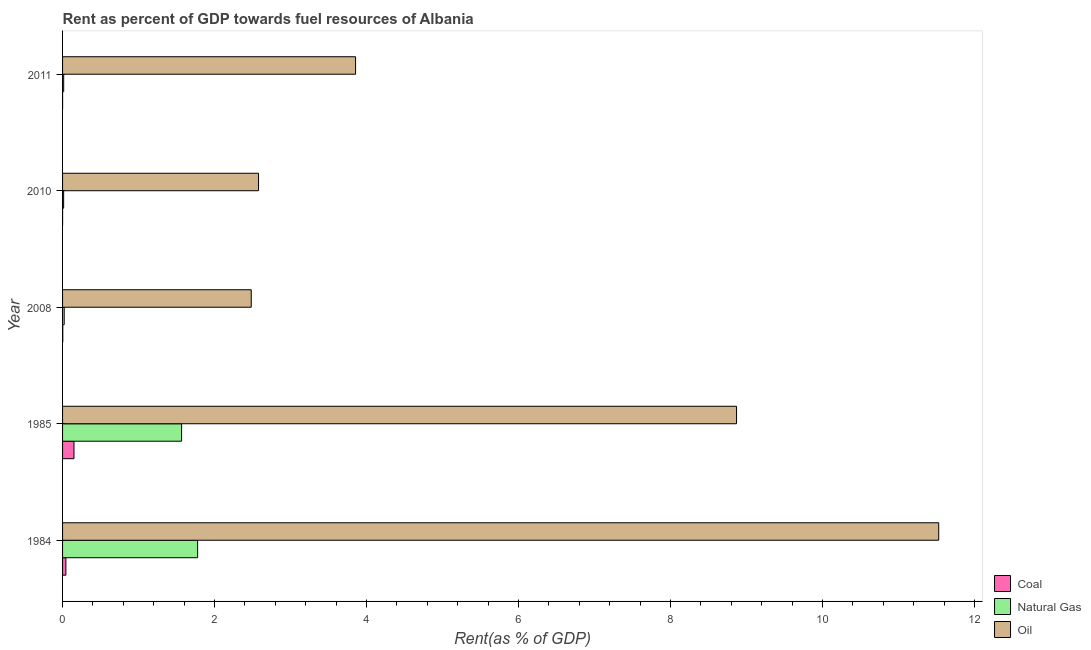How many groups of bars are there?
Provide a short and direct response. 5. How many bars are there on the 3rd tick from the bottom?
Your answer should be compact. 3. What is the rent towards coal in 2010?
Your response must be concise. 0. Across all years, what is the maximum rent towards coal?
Give a very brief answer. 0.15. Across all years, what is the minimum rent towards coal?
Your answer should be compact. 0. In which year was the rent towards oil minimum?
Offer a terse response. 2008. What is the total rent towards coal in the graph?
Your response must be concise. 0.2. What is the difference between the rent towards coal in 1984 and that in 2010?
Your answer should be very brief. 0.04. What is the difference between the rent towards coal in 1984 and the rent towards natural gas in 2010?
Provide a succinct answer. 0.03. What is the average rent towards natural gas per year?
Your answer should be compact. 0.68. In the year 2008, what is the difference between the rent towards oil and rent towards coal?
Your response must be concise. 2.48. In how many years, is the rent towards natural gas greater than 1.2000000000000002 %?
Offer a very short reply. 2. What is the ratio of the rent towards coal in 1984 to that in 2011?
Provide a short and direct response. 172.49. What is the difference between the highest and the second highest rent towards natural gas?
Offer a terse response. 0.21. What is the difference between the highest and the lowest rent towards natural gas?
Offer a terse response. 1.76. In how many years, is the rent towards coal greater than the average rent towards coal taken over all years?
Keep it short and to the point. 2. Is the sum of the rent towards natural gas in 1985 and 2008 greater than the maximum rent towards oil across all years?
Your answer should be compact. No. What does the 1st bar from the top in 1984 represents?
Your answer should be compact. Oil. What does the 1st bar from the bottom in 1985 represents?
Offer a terse response. Coal. How many years are there in the graph?
Keep it short and to the point. 5. Does the graph contain any zero values?
Offer a very short reply. No. Where does the legend appear in the graph?
Offer a terse response. Bottom right. What is the title of the graph?
Make the answer very short. Rent as percent of GDP towards fuel resources of Albania. Does "Secondary education" appear as one of the legend labels in the graph?
Provide a succinct answer. No. What is the label or title of the X-axis?
Give a very brief answer. Rent(as % of GDP). What is the Rent(as % of GDP) in Coal in 1984?
Ensure brevity in your answer.  0.04. What is the Rent(as % of GDP) in Natural Gas in 1984?
Offer a very short reply. 1.78. What is the Rent(as % of GDP) in Oil in 1984?
Provide a short and direct response. 11.53. What is the Rent(as % of GDP) in Coal in 1985?
Provide a succinct answer. 0.15. What is the Rent(as % of GDP) of Natural Gas in 1985?
Make the answer very short. 1.57. What is the Rent(as % of GDP) of Oil in 1985?
Ensure brevity in your answer.  8.87. What is the Rent(as % of GDP) of Coal in 2008?
Keep it short and to the point. 0. What is the Rent(as % of GDP) in Natural Gas in 2008?
Ensure brevity in your answer.  0.02. What is the Rent(as % of GDP) of Oil in 2008?
Give a very brief answer. 2.48. What is the Rent(as % of GDP) of Coal in 2010?
Provide a short and direct response. 0. What is the Rent(as % of GDP) in Natural Gas in 2010?
Your response must be concise. 0.01. What is the Rent(as % of GDP) in Oil in 2010?
Offer a very short reply. 2.58. What is the Rent(as % of GDP) of Coal in 2011?
Provide a succinct answer. 0. What is the Rent(as % of GDP) of Natural Gas in 2011?
Provide a succinct answer. 0.01. What is the Rent(as % of GDP) of Oil in 2011?
Offer a very short reply. 3.86. Across all years, what is the maximum Rent(as % of GDP) in Coal?
Provide a short and direct response. 0.15. Across all years, what is the maximum Rent(as % of GDP) in Natural Gas?
Provide a succinct answer. 1.78. Across all years, what is the maximum Rent(as % of GDP) in Oil?
Give a very brief answer. 11.53. Across all years, what is the minimum Rent(as % of GDP) of Coal?
Provide a succinct answer. 0. Across all years, what is the minimum Rent(as % of GDP) of Natural Gas?
Make the answer very short. 0.01. Across all years, what is the minimum Rent(as % of GDP) in Oil?
Make the answer very short. 2.48. What is the total Rent(as % of GDP) in Coal in the graph?
Offer a terse response. 0.2. What is the total Rent(as % of GDP) in Natural Gas in the graph?
Ensure brevity in your answer.  3.39. What is the total Rent(as % of GDP) in Oil in the graph?
Provide a succinct answer. 29.32. What is the difference between the Rent(as % of GDP) in Coal in 1984 and that in 1985?
Offer a terse response. -0.11. What is the difference between the Rent(as % of GDP) in Natural Gas in 1984 and that in 1985?
Keep it short and to the point. 0.21. What is the difference between the Rent(as % of GDP) of Oil in 1984 and that in 1985?
Provide a succinct answer. 2.66. What is the difference between the Rent(as % of GDP) in Coal in 1984 and that in 2008?
Your answer should be very brief. 0.04. What is the difference between the Rent(as % of GDP) in Natural Gas in 1984 and that in 2008?
Provide a succinct answer. 1.76. What is the difference between the Rent(as % of GDP) in Oil in 1984 and that in 2008?
Give a very brief answer. 9.05. What is the difference between the Rent(as % of GDP) in Coal in 1984 and that in 2010?
Your response must be concise. 0.04. What is the difference between the Rent(as % of GDP) in Natural Gas in 1984 and that in 2010?
Make the answer very short. 1.76. What is the difference between the Rent(as % of GDP) of Oil in 1984 and that in 2010?
Provide a short and direct response. 8.95. What is the difference between the Rent(as % of GDP) of Coal in 1984 and that in 2011?
Give a very brief answer. 0.04. What is the difference between the Rent(as % of GDP) of Natural Gas in 1984 and that in 2011?
Your response must be concise. 1.76. What is the difference between the Rent(as % of GDP) of Oil in 1984 and that in 2011?
Offer a very short reply. 7.67. What is the difference between the Rent(as % of GDP) in Coal in 1985 and that in 2008?
Keep it short and to the point. 0.15. What is the difference between the Rent(as % of GDP) of Natural Gas in 1985 and that in 2008?
Your response must be concise. 1.54. What is the difference between the Rent(as % of GDP) of Oil in 1985 and that in 2008?
Provide a short and direct response. 6.39. What is the difference between the Rent(as % of GDP) of Coal in 1985 and that in 2010?
Offer a terse response. 0.15. What is the difference between the Rent(as % of GDP) in Natural Gas in 1985 and that in 2010?
Keep it short and to the point. 1.55. What is the difference between the Rent(as % of GDP) in Oil in 1985 and that in 2010?
Ensure brevity in your answer.  6.29. What is the difference between the Rent(as % of GDP) in Coal in 1985 and that in 2011?
Ensure brevity in your answer.  0.15. What is the difference between the Rent(as % of GDP) of Natural Gas in 1985 and that in 2011?
Keep it short and to the point. 1.55. What is the difference between the Rent(as % of GDP) of Oil in 1985 and that in 2011?
Give a very brief answer. 5.01. What is the difference between the Rent(as % of GDP) of Coal in 2008 and that in 2010?
Your response must be concise. 0. What is the difference between the Rent(as % of GDP) of Natural Gas in 2008 and that in 2010?
Your response must be concise. 0.01. What is the difference between the Rent(as % of GDP) of Oil in 2008 and that in 2010?
Make the answer very short. -0.1. What is the difference between the Rent(as % of GDP) in Coal in 2008 and that in 2011?
Make the answer very short. 0. What is the difference between the Rent(as % of GDP) in Natural Gas in 2008 and that in 2011?
Your answer should be very brief. 0.01. What is the difference between the Rent(as % of GDP) in Oil in 2008 and that in 2011?
Give a very brief answer. -1.37. What is the difference between the Rent(as % of GDP) of Coal in 2010 and that in 2011?
Ensure brevity in your answer.  -0. What is the difference between the Rent(as % of GDP) in Natural Gas in 2010 and that in 2011?
Offer a terse response. -0. What is the difference between the Rent(as % of GDP) in Oil in 2010 and that in 2011?
Your answer should be compact. -1.28. What is the difference between the Rent(as % of GDP) of Coal in 1984 and the Rent(as % of GDP) of Natural Gas in 1985?
Offer a terse response. -1.52. What is the difference between the Rent(as % of GDP) of Coal in 1984 and the Rent(as % of GDP) of Oil in 1985?
Your response must be concise. -8.83. What is the difference between the Rent(as % of GDP) of Natural Gas in 1984 and the Rent(as % of GDP) of Oil in 1985?
Provide a succinct answer. -7.09. What is the difference between the Rent(as % of GDP) in Coal in 1984 and the Rent(as % of GDP) in Natural Gas in 2008?
Your response must be concise. 0.02. What is the difference between the Rent(as % of GDP) of Coal in 1984 and the Rent(as % of GDP) of Oil in 2008?
Make the answer very short. -2.44. What is the difference between the Rent(as % of GDP) in Natural Gas in 1984 and the Rent(as % of GDP) in Oil in 2008?
Your response must be concise. -0.71. What is the difference between the Rent(as % of GDP) of Coal in 1984 and the Rent(as % of GDP) of Natural Gas in 2010?
Keep it short and to the point. 0.03. What is the difference between the Rent(as % of GDP) in Coal in 1984 and the Rent(as % of GDP) in Oil in 2010?
Give a very brief answer. -2.54. What is the difference between the Rent(as % of GDP) in Natural Gas in 1984 and the Rent(as % of GDP) in Oil in 2010?
Your answer should be compact. -0.8. What is the difference between the Rent(as % of GDP) in Coal in 1984 and the Rent(as % of GDP) in Natural Gas in 2011?
Keep it short and to the point. 0.03. What is the difference between the Rent(as % of GDP) of Coal in 1984 and the Rent(as % of GDP) of Oil in 2011?
Make the answer very short. -3.81. What is the difference between the Rent(as % of GDP) in Natural Gas in 1984 and the Rent(as % of GDP) in Oil in 2011?
Your response must be concise. -2.08. What is the difference between the Rent(as % of GDP) of Coal in 1985 and the Rent(as % of GDP) of Natural Gas in 2008?
Keep it short and to the point. 0.13. What is the difference between the Rent(as % of GDP) in Coal in 1985 and the Rent(as % of GDP) in Oil in 2008?
Keep it short and to the point. -2.33. What is the difference between the Rent(as % of GDP) in Natural Gas in 1985 and the Rent(as % of GDP) in Oil in 2008?
Keep it short and to the point. -0.92. What is the difference between the Rent(as % of GDP) of Coal in 1985 and the Rent(as % of GDP) of Natural Gas in 2010?
Your response must be concise. 0.14. What is the difference between the Rent(as % of GDP) in Coal in 1985 and the Rent(as % of GDP) in Oil in 2010?
Make the answer very short. -2.43. What is the difference between the Rent(as % of GDP) of Natural Gas in 1985 and the Rent(as % of GDP) of Oil in 2010?
Keep it short and to the point. -1.01. What is the difference between the Rent(as % of GDP) in Coal in 1985 and the Rent(as % of GDP) in Natural Gas in 2011?
Your answer should be compact. 0.14. What is the difference between the Rent(as % of GDP) of Coal in 1985 and the Rent(as % of GDP) of Oil in 2011?
Give a very brief answer. -3.71. What is the difference between the Rent(as % of GDP) in Natural Gas in 1985 and the Rent(as % of GDP) in Oil in 2011?
Provide a succinct answer. -2.29. What is the difference between the Rent(as % of GDP) in Coal in 2008 and the Rent(as % of GDP) in Natural Gas in 2010?
Offer a terse response. -0.01. What is the difference between the Rent(as % of GDP) in Coal in 2008 and the Rent(as % of GDP) in Oil in 2010?
Offer a terse response. -2.58. What is the difference between the Rent(as % of GDP) in Natural Gas in 2008 and the Rent(as % of GDP) in Oil in 2010?
Keep it short and to the point. -2.56. What is the difference between the Rent(as % of GDP) in Coal in 2008 and the Rent(as % of GDP) in Natural Gas in 2011?
Provide a short and direct response. -0.01. What is the difference between the Rent(as % of GDP) of Coal in 2008 and the Rent(as % of GDP) of Oil in 2011?
Your response must be concise. -3.85. What is the difference between the Rent(as % of GDP) in Natural Gas in 2008 and the Rent(as % of GDP) in Oil in 2011?
Your response must be concise. -3.83. What is the difference between the Rent(as % of GDP) of Coal in 2010 and the Rent(as % of GDP) of Natural Gas in 2011?
Your response must be concise. -0.01. What is the difference between the Rent(as % of GDP) of Coal in 2010 and the Rent(as % of GDP) of Oil in 2011?
Keep it short and to the point. -3.86. What is the difference between the Rent(as % of GDP) in Natural Gas in 2010 and the Rent(as % of GDP) in Oil in 2011?
Your answer should be compact. -3.84. What is the average Rent(as % of GDP) in Coal per year?
Offer a very short reply. 0.04. What is the average Rent(as % of GDP) in Natural Gas per year?
Your response must be concise. 0.68. What is the average Rent(as % of GDP) of Oil per year?
Your answer should be compact. 5.86. In the year 1984, what is the difference between the Rent(as % of GDP) in Coal and Rent(as % of GDP) in Natural Gas?
Offer a very short reply. -1.73. In the year 1984, what is the difference between the Rent(as % of GDP) in Coal and Rent(as % of GDP) in Oil?
Offer a terse response. -11.49. In the year 1984, what is the difference between the Rent(as % of GDP) of Natural Gas and Rent(as % of GDP) of Oil?
Your response must be concise. -9.75. In the year 1985, what is the difference between the Rent(as % of GDP) of Coal and Rent(as % of GDP) of Natural Gas?
Keep it short and to the point. -1.42. In the year 1985, what is the difference between the Rent(as % of GDP) of Coal and Rent(as % of GDP) of Oil?
Offer a very short reply. -8.72. In the year 1985, what is the difference between the Rent(as % of GDP) of Natural Gas and Rent(as % of GDP) of Oil?
Give a very brief answer. -7.3. In the year 2008, what is the difference between the Rent(as % of GDP) of Coal and Rent(as % of GDP) of Natural Gas?
Keep it short and to the point. -0.02. In the year 2008, what is the difference between the Rent(as % of GDP) in Coal and Rent(as % of GDP) in Oil?
Provide a short and direct response. -2.48. In the year 2008, what is the difference between the Rent(as % of GDP) in Natural Gas and Rent(as % of GDP) in Oil?
Offer a very short reply. -2.46. In the year 2010, what is the difference between the Rent(as % of GDP) in Coal and Rent(as % of GDP) in Natural Gas?
Make the answer very short. -0.01. In the year 2010, what is the difference between the Rent(as % of GDP) in Coal and Rent(as % of GDP) in Oil?
Your response must be concise. -2.58. In the year 2010, what is the difference between the Rent(as % of GDP) in Natural Gas and Rent(as % of GDP) in Oil?
Keep it short and to the point. -2.56. In the year 2011, what is the difference between the Rent(as % of GDP) in Coal and Rent(as % of GDP) in Natural Gas?
Your answer should be very brief. -0.01. In the year 2011, what is the difference between the Rent(as % of GDP) in Coal and Rent(as % of GDP) in Oil?
Give a very brief answer. -3.86. In the year 2011, what is the difference between the Rent(as % of GDP) in Natural Gas and Rent(as % of GDP) in Oil?
Give a very brief answer. -3.84. What is the ratio of the Rent(as % of GDP) of Coal in 1984 to that in 1985?
Give a very brief answer. 0.29. What is the ratio of the Rent(as % of GDP) of Natural Gas in 1984 to that in 1985?
Keep it short and to the point. 1.13. What is the ratio of the Rent(as % of GDP) of Oil in 1984 to that in 1985?
Your answer should be very brief. 1.3. What is the ratio of the Rent(as % of GDP) in Coal in 1984 to that in 2008?
Your answer should be compact. 14.99. What is the ratio of the Rent(as % of GDP) in Natural Gas in 1984 to that in 2008?
Provide a short and direct response. 82.85. What is the ratio of the Rent(as % of GDP) of Oil in 1984 to that in 2008?
Provide a short and direct response. 4.64. What is the ratio of the Rent(as % of GDP) of Coal in 1984 to that in 2010?
Make the answer very short. 347.91. What is the ratio of the Rent(as % of GDP) of Natural Gas in 1984 to that in 2010?
Give a very brief answer. 125.7. What is the ratio of the Rent(as % of GDP) of Oil in 1984 to that in 2010?
Offer a terse response. 4.47. What is the ratio of the Rent(as % of GDP) in Coal in 1984 to that in 2011?
Keep it short and to the point. 172.49. What is the ratio of the Rent(as % of GDP) in Natural Gas in 1984 to that in 2011?
Provide a succinct answer. 120.52. What is the ratio of the Rent(as % of GDP) in Oil in 1984 to that in 2011?
Keep it short and to the point. 2.99. What is the ratio of the Rent(as % of GDP) in Coal in 1985 to that in 2008?
Your answer should be very brief. 51.55. What is the ratio of the Rent(as % of GDP) in Natural Gas in 1985 to that in 2008?
Make the answer very short. 73.02. What is the ratio of the Rent(as % of GDP) in Oil in 1985 to that in 2008?
Give a very brief answer. 3.57. What is the ratio of the Rent(as % of GDP) in Coal in 1985 to that in 2010?
Offer a very short reply. 1196.46. What is the ratio of the Rent(as % of GDP) in Natural Gas in 1985 to that in 2010?
Ensure brevity in your answer.  110.78. What is the ratio of the Rent(as % of GDP) in Oil in 1985 to that in 2010?
Your answer should be compact. 3.44. What is the ratio of the Rent(as % of GDP) of Coal in 1985 to that in 2011?
Your response must be concise. 593.21. What is the ratio of the Rent(as % of GDP) of Natural Gas in 1985 to that in 2011?
Your answer should be compact. 106.22. What is the ratio of the Rent(as % of GDP) in Oil in 1985 to that in 2011?
Your response must be concise. 2.3. What is the ratio of the Rent(as % of GDP) in Coal in 2008 to that in 2010?
Offer a very short reply. 23.21. What is the ratio of the Rent(as % of GDP) of Natural Gas in 2008 to that in 2010?
Your answer should be very brief. 1.52. What is the ratio of the Rent(as % of GDP) of Oil in 2008 to that in 2010?
Provide a short and direct response. 0.96. What is the ratio of the Rent(as % of GDP) of Coal in 2008 to that in 2011?
Offer a terse response. 11.51. What is the ratio of the Rent(as % of GDP) in Natural Gas in 2008 to that in 2011?
Keep it short and to the point. 1.45. What is the ratio of the Rent(as % of GDP) of Oil in 2008 to that in 2011?
Make the answer very short. 0.64. What is the ratio of the Rent(as % of GDP) of Coal in 2010 to that in 2011?
Make the answer very short. 0.5. What is the ratio of the Rent(as % of GDP) in Natural Gas in 2010 to that in 2011?
Give a very brief answer. 0.96. What is the ratio of the Rent(as % of GDP) in Oil in 2010 to that in 2011?
Provide a succinct answer. 0.67. What is the difference between the highest and the second highest Rent(as % of GDP) of Coal?
Offer a terse response. 0.11. What is the difference between the highest and the second highest Rent(as % of GDP) of Natural Gas?
Your answer should be very brief. 0.21. What is the difference between the highest and the second highest Rent(as % of GDP) in Oil?
Give a very brief answer. 2.66. What is the difference between the highest and the lowest Rent(as % of GDP) of Coal?
Ensure brevity in your answer.  0.15. What is the difference between the highest and the lowest Rent(as % of GDP) of Natural Gas?
Your answer should be very brief. 1.76. What is the difference between the highest and the lowest Rent(as % of GDP) in Oil?
Your answer should be compact. 9.05. 